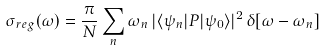Convert formula to latex. <formula><loc_0><loc_0><loc_500><loc_500>\sigma _ { r e g } ( \omega ) = \frac { \pi } { N } \sum _ { n } \omega _ { n } \, | \langle \psi _ { n } | P | \psi _ { 0 } \rangle | ^ { 2 } \, \delta [ \omega - \omega _ { n } ]</formula> 